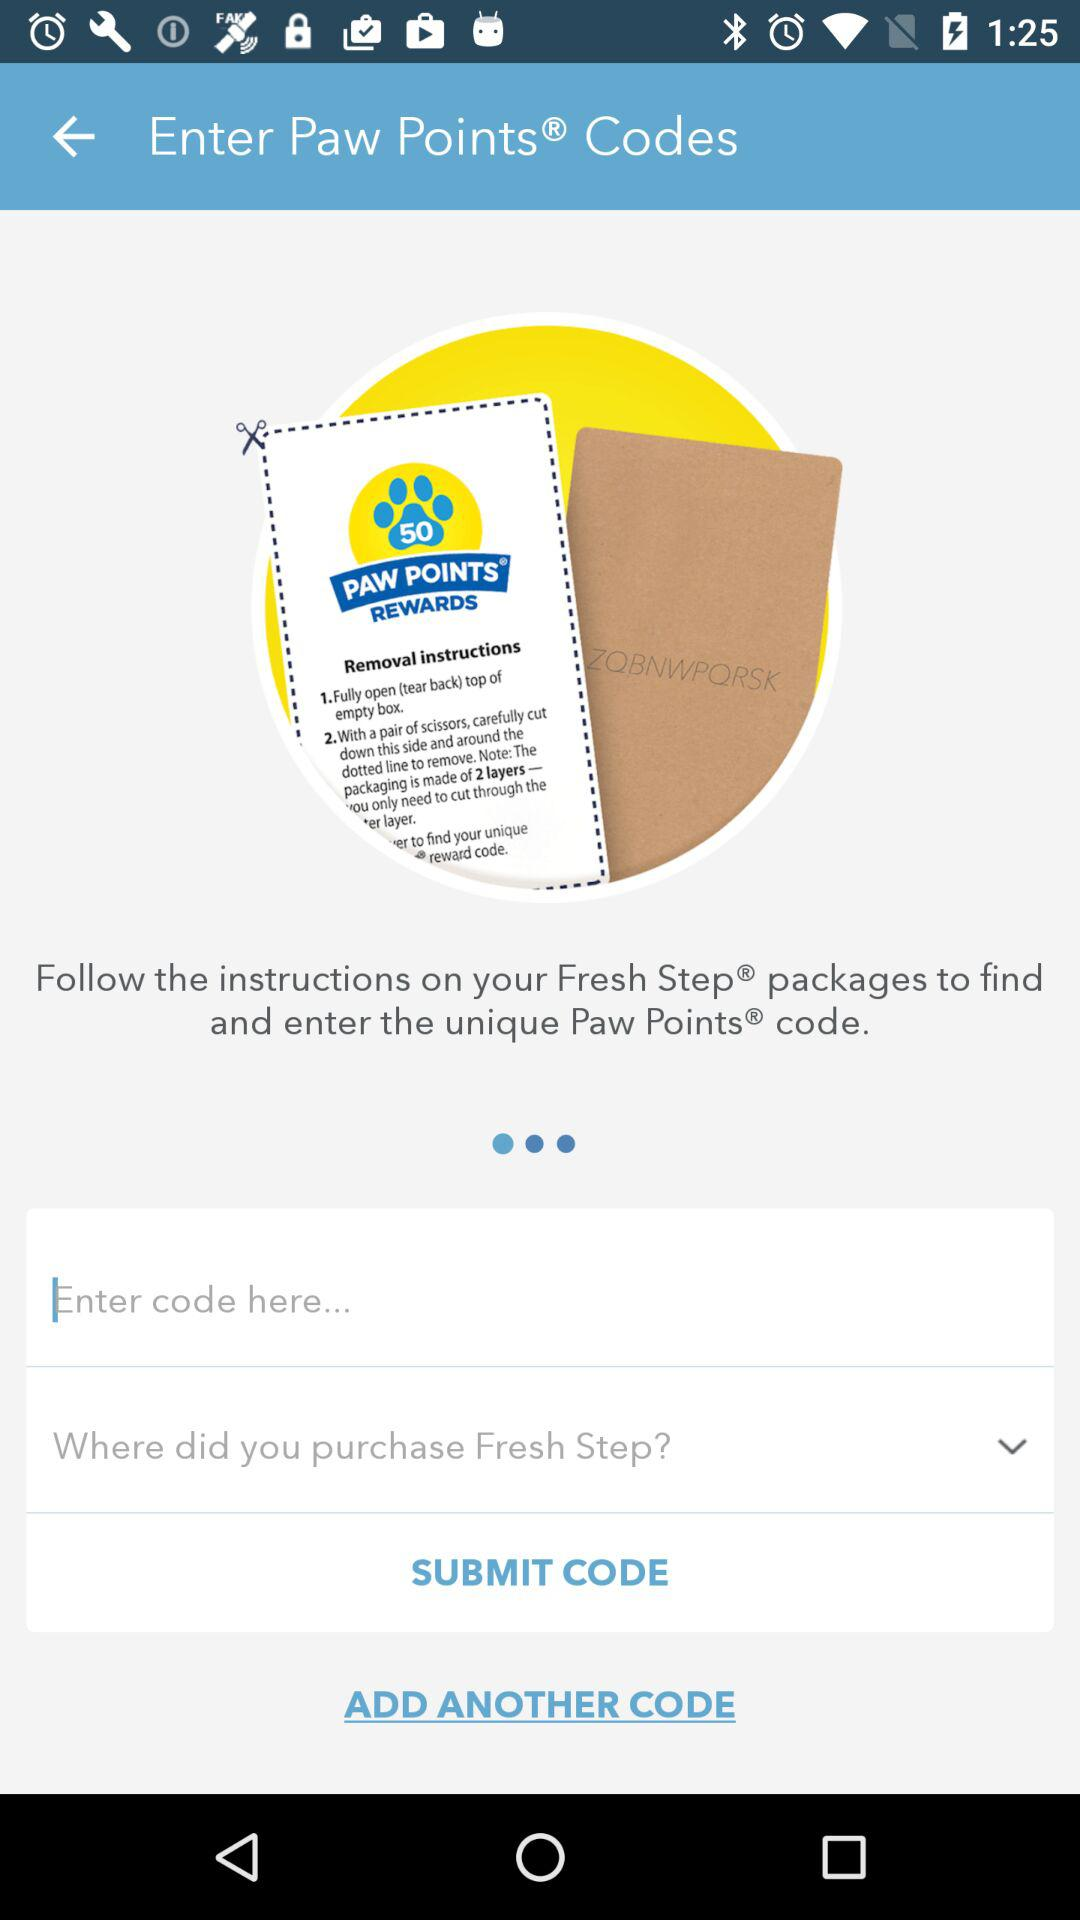What is the mentioned number of Paw Points? The mentioned number of Paw Points is 50. 